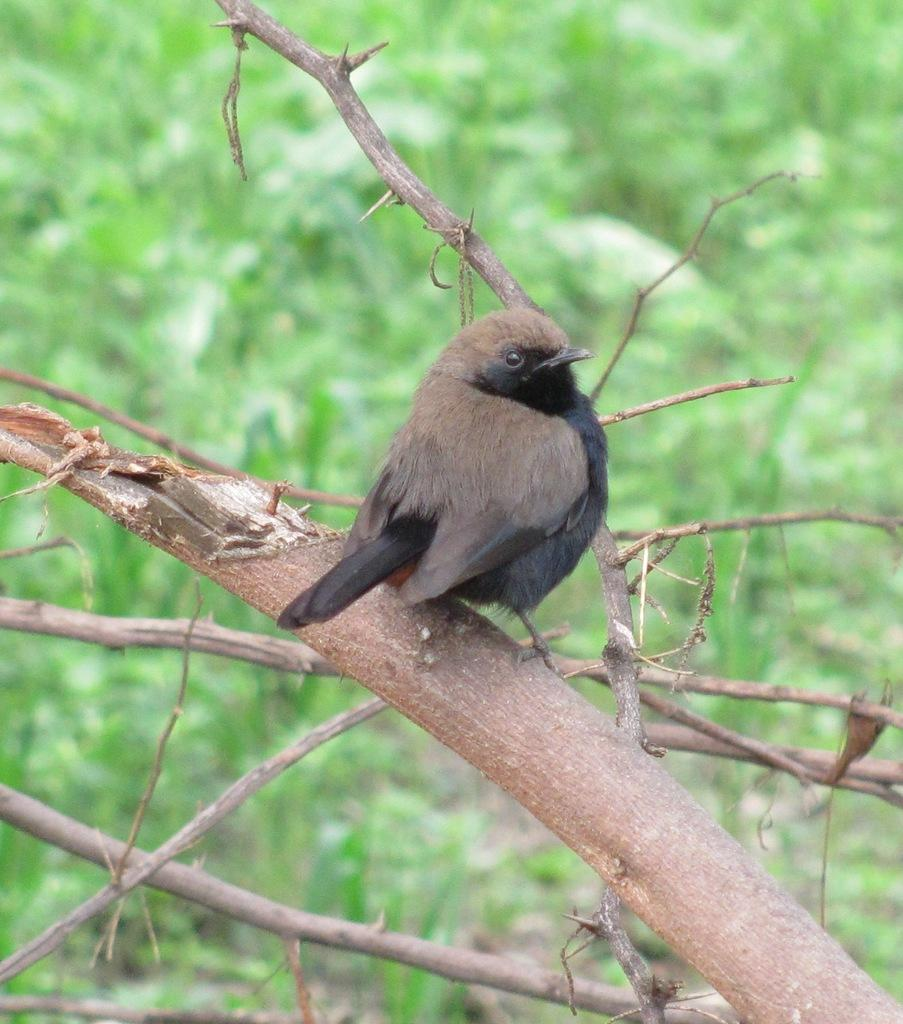What type of animal is in the image? There is a bird in the image. Where is the bird located? The bird is standing on a branch of a tree. What color is the background behind the bird? The background of the bird is blue. How does the bird push the bushes aside in the image? There are no bushes present in the image, and the bird is not shown pushing anything aside. 